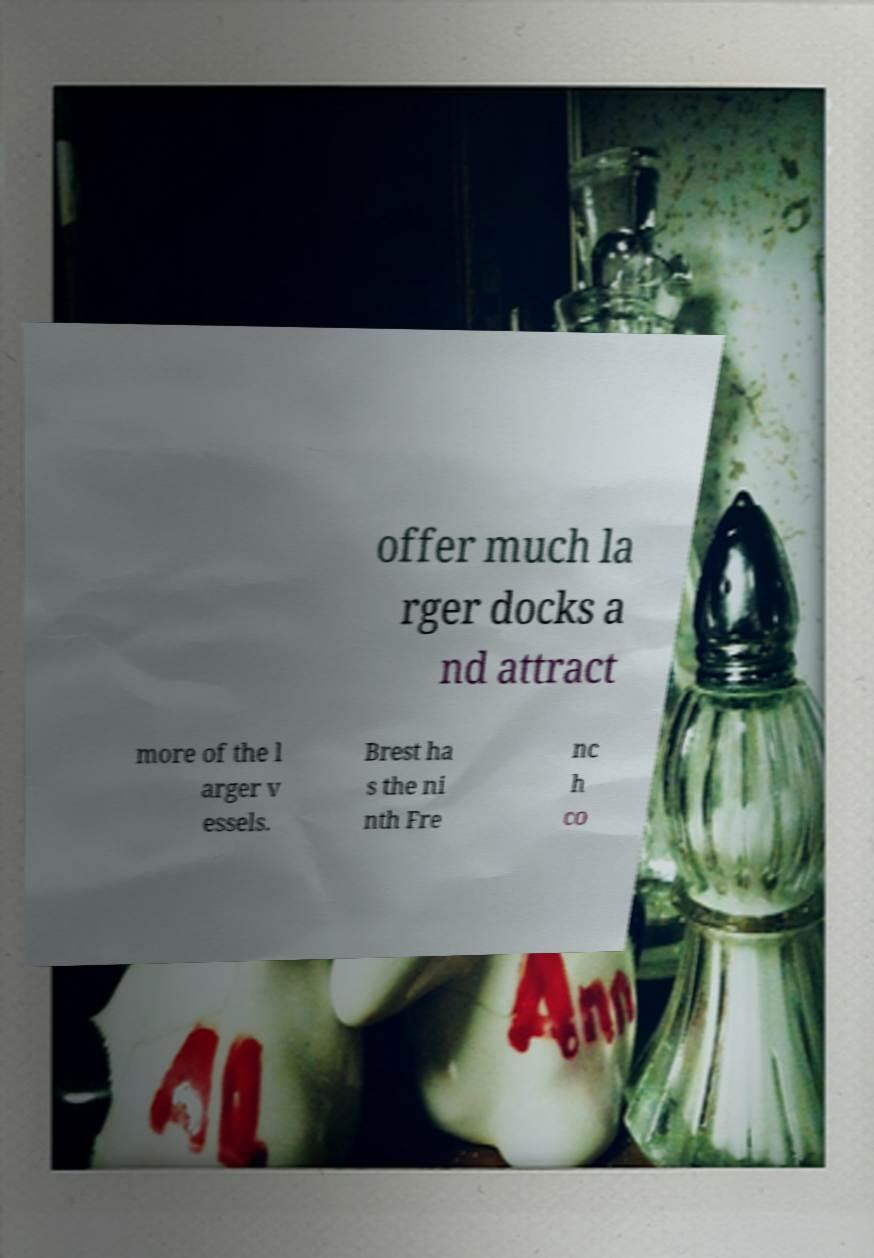What messages or text are displayed in this image? I need them in a readable, typed format. offer much la rger docks a nd attract more of the l arger v essels. Brest ha s the ni nth Fre nc h co 